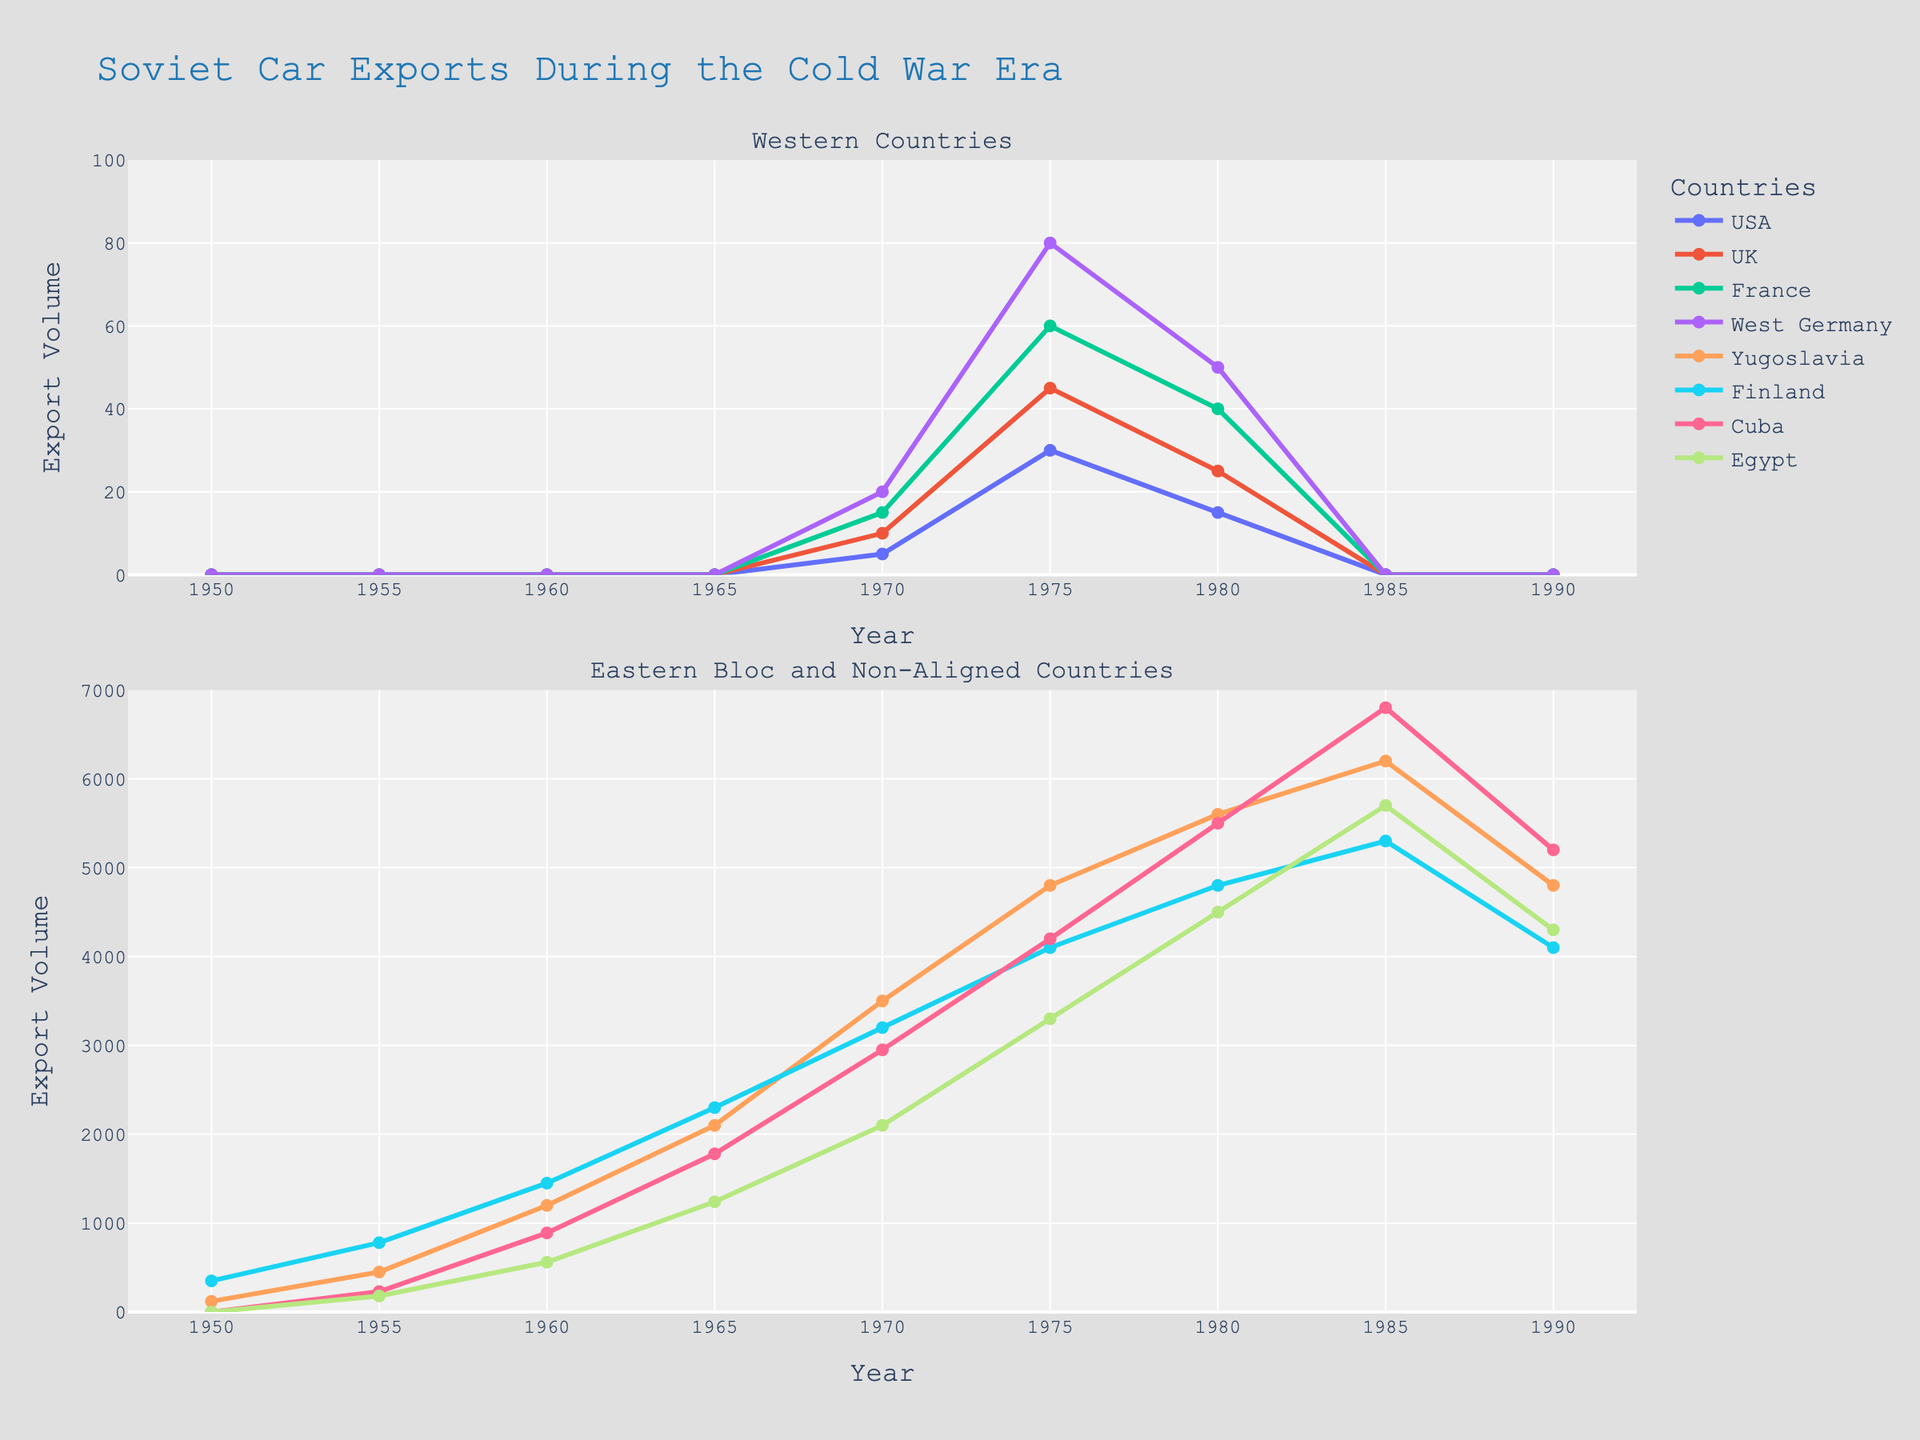Which country had the highest export volume in 1985? Observing the 'Eastern Bloc and Non-Aligned Countries' subplot, you can see Cuba's export volume reaches the highest point for 1985.
Answer: Cuba What was the total export volume for Yugoslavia and Finland in 1975? From the 'Eastern Bloc and Non-Aligned Countries' subplot, we see that the export volumes for Yugoslavia and Finland in 1975 are 4800 and 4100, respectively. Summing these values gives 4800 + 4100 = 8900.
Answer: 8900 Did the USA import more cars in 1975 or 1980? Comparing the USA export volumes in the ‘Western Countries’ subplot, we see that the USA imported 30 cars in 1975 and 15 cars in 1980. Hence, the import volume was higher in 1975.
Answer: 1975 By how much did the export volume to Egypt increase from 1955 to 1965? In the 'Eastern Bloc and Non-Aligned Countries' subplot, Egypt's export volume was 180 in 1955 and 1240 in 1965. The increase is calculated as 1240 - 180 = 1060.
Answer: 1060 Which country experienced a decline in export volume from 1985 to 1990? Observing the 'Eastern Bloc and Non-Aligned Countries' subplot, both Finland and Cuba saw a decrease in export volumes from 1985 to 1990, with Finland from 5300 to 4100 and Cuba from 6800 to 5200.
Answer: Finland, Cuba In which year did automobiles export to the UK reach its peak? From the 'Western Countries' subplot, the export volume to the UK reached its peak in 1975.
Answer: 1975 Compare the export trends between Finland and Egypt from 1950 to 1990. Observing the 'Eastern Bloc and Non-Aligned Countries' subplot, both Finland and Egypt show a generally increasing trend, peaking in 1985. Finland's exports were consistently higher than Egypt's throughout the years shown.
Answer: Generally increasing, Finland consistently higher What is the average export volume to France across the recorded years? From the 'Western Countries' subplot, export volumes to France are: 0, 0, 0, 0, 15, 60, 40, 0, 0. Average = (0+0+0+0+15+60+40+0+0) / 9 = 115 / 9 = 12.78 (approx).
Answer: 12.78 